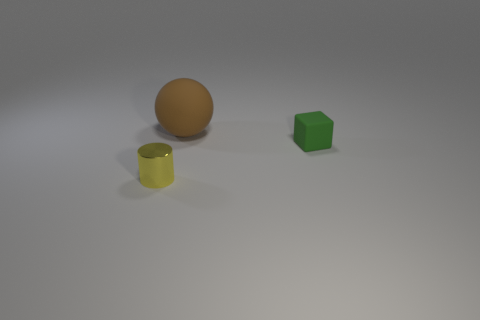There is a matte thing that is to the right of the rubber thing that is on the left side of the green block; what is its shape?
Your answer should be compact. Cube. How many things are green things or small objects on the right side of the small yellow cylinder?
Give a very brief answer. 1. How many other objects are there of the same color as the tiny rubber object?
Offer a terse response. 0. What number of blue objects are either big metal balls or tiny matte cubes?
Provide a short and direct response. 0. There is a thing to the right of the brown ball on the left side of the green object; are there any large brown matte objects left of it?
Make the answer very short. Yes. Is there anything else that has the same size as the matte sphere?
Make the answer very short. No. What is the color of the object that is behind the matte object that is in front of the large thing?
Keep it short and to the point. Brown. What number of tiny things are red metallic objects or brown objects?
Provide a short and direct response. 0. The object that is both in front of the large brown matte object and to the left of the tiny green thing is what color?
Provide a short and direct response. Yellow. Do the large brown thing and the cylinder have the same material?
Your answer should be very brief. No. 